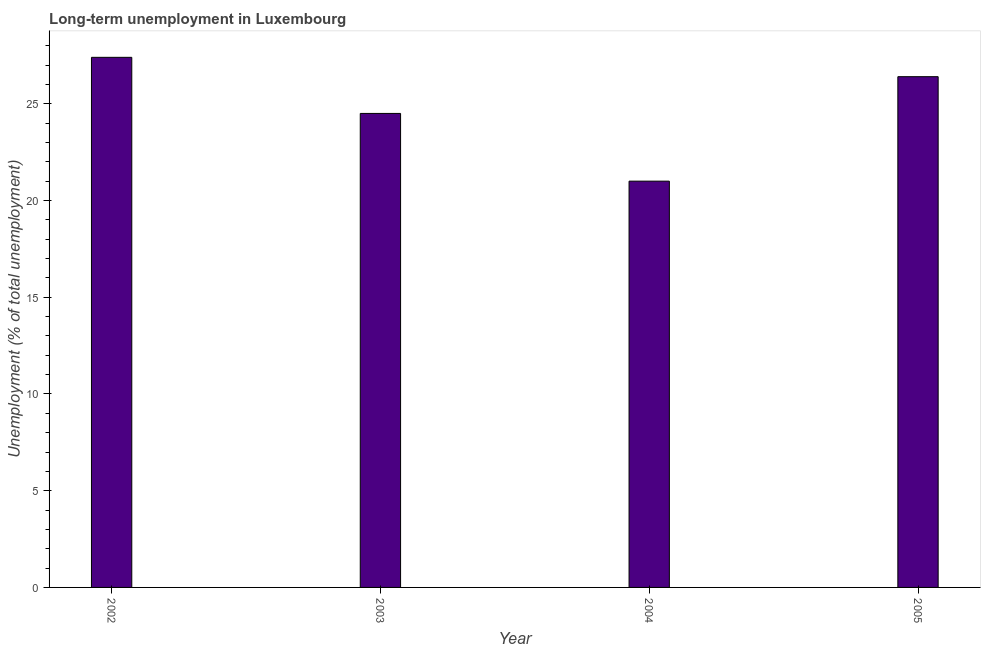Does the graph contain grids?
Provide a short and direct response. No. What is the title of the graph?
Your response must be concise. Long-term unemployment in Luxembourg. What is the label or title of the X-axis?
Keep it short and to the point. Year. What is the label or title of the Y-axis?
Provide a succinct answer. Unemployment (% of total unemployment). What is the long-term unemployment in 2002?
Your answer should be compact. 27.4. Across all years, what is the maximum long-term unemployment?
Offer a terse response. 27.4. In which year was the long-term unemployment maximum?
Keep it short and to the point. 2002. What is the sum of the long-term unemployment?
Ensure brevity in your answer.  99.3. What is the difference between the long-term unemployment in 2002 and 2005?
Keep it short and to the point. 1. What is the average long-term unemployment per year?
Provide a succinct answer. 24.82. What is the median long-term unemployment?
Offer a very short reply. 25.45. What is the ratio of the long-term unemployment in 2003 to that in 2005?
Your response must be concise. 0.93. What is the difference between the highest and the second highest long-term unemployment?
Provide a succinct answer. 1. Is the sum of the long-term unemployment in 2002 and 2003 greater than the maximum long-term unemployment across all years?
Your answer should be compact. Yes. In how many years, is the long-term unemployment greater than the average long-term unemployment taken over all years?
Make the answer very short. 2. How many bars are there?
Provide a succinct answer. 4. What is the difference between two consecutive major ticks on the Y-axis?
Provide a short and direct response. 5. What is the Unemployment (% of total unemployment) in 2002?
Make the answer very short. 27.4. What is the Unemployment (% of total unemployment) in 2003?
Your answer should be very brief. 24.5. What is the Unemployment (% of total unemployment) in 2005?
Offer a very short reply. 26.4. What is the difference between the Unemployment (% of total unemployment) in 2002 and 2003?
Your answer should be very brief. 2.9. What is the difference between the Unemployment (% of total unemployment) in 2002 and 2005?
Provide a succinct answer. 1. What is the difference between the Unemployment (% of total unemployment) in 2003 and 2005?
Keep it short and to the point. -1.9. What is the ratio of the Unemployment (% of total unemployment) in 2002 to that in 2003?
Your response must be concise. 1.12. What is the ratio of the Unemployment (% of total unemployment) in 2002 to that in 2004?
Make the answer very short. 1.3. What is the ratio of the Unemployment (% of total unemployment) in 2002 to that in 2005?
Ensure brevity in your answer.  1.04. What is the ratio of the Unemployment (% of total unemployment) in 2003 to that in 2004?
Provide a succinct answer. 1.17. What is the ratio of the Unemployment (% of total unemployment) in 2003 to that in 2005?
Provide a short and direct response. 0.93. What is the ratio of the Unemployment (% of total unemployment) in 2004 to that in 2005?
Offer a terse response. 0.8. 